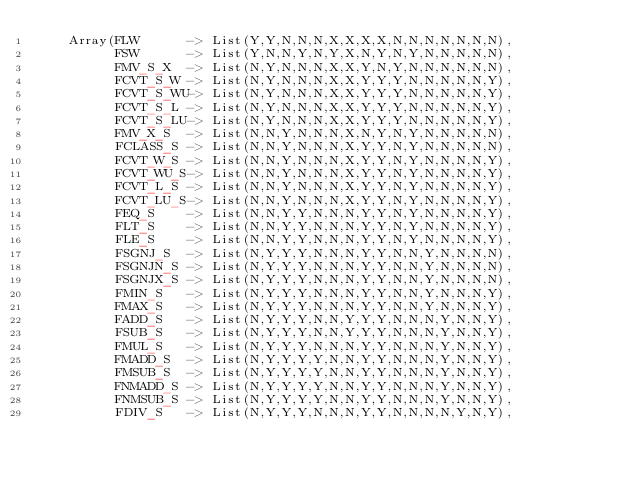Convert code to text. <code><loc_0><loc_0><loc_500><loc_500><_Scala_>    Array(FLW      -> List(Y,Y,N,N,N,X,X,X,X,N,N,N,N,N,N,N),
          FSW      -> List(Y,N,N,Y,N,Y,X,N,Y,N,Y,N,N,N,N,N),
          FMV_S_X  -> List(N,Y,N,N,N,X,X,Y,N,Y,N,N,N,N,N,N),
          FCVT_S_W -> List(N,Y,N,N,N,X,X,Y,Y,Y,N,N,N,N,N,Y),
          FCVT_S_WU-> List(N,Y,N,N,N,X,X,Y,Y,Y,N,N,N,N,N,Y),
          FCVT_S_L -> List(N,Y,N,N,N,X,X,Y,Y,Y,N,N,N,N,N,Y),
          FCVT_S_LU-> List(N,Y,N,N,N,X,X,Y,Y,Y,N,N,N,N,N,Y),
          FMV_X_S  -> List(N,N,Y,N,N,N,X,N,Y,N,Y,N,N,N,N,N),
          FCLASS_S -> List(N,N,Y,N,N,N,X,Y,Y,N,Y,N,N,N,N,N),
          FCVT_W_S -> List(N,N,Y,N,N,N,X,Y,Y,N,Y,N,N,N,N,Y),
          FCVT_WU_S-> List(N,N,Y,N,N,N,X,Y,Y,N,Y,N,N,N,N,Y),
          FCVT_L_S -> List(N,N,Y,N,N,N,X,Y,Y,N,Y,N,N,N,N,Y),
          FCVT_LU_S-> List(N,N,Y,N,N,N,X,Y,Y,N,Y,N,N,N,N,Y),
          FEQ_S    -> List(N,N,Y,Y,N,N,N,Y,Y,N,Y,N,N,N,N,Y),
          FLT_S    -> List(N,N,Y,Y,N,N,N,Y,Y,N,Y,N,N,N,N,Y),
          FLE_S    -> List(N,N,Y,Y,N,N,N,Y,Y,N,Y,N,N,N,N,Y),
          FSGNJ_S  -> List(N,Y,Y,Y,N,N,N,Y,Y,N,N,Y,N,N,N,N),
          FSGNJN_S -> List(N,Y,Y,Y,N,N,N,Y,Y,N,N,Y,N,N,N,N),
          FSGNJX_S -> List(N,Y,Y,Y,N,N,N,Y,Y,N,N,Y,N,N,N,N),
          FMIN_S   -> List(N,Y,Y,Y,N,N,N,Y,Y,N,N,Y,N,N,N,Y),
          FMAX_S   -> List(N,Y,Y,Y,N,N,N,Y,Y,N,N,Y,N,N,N,Y),
          FADD_S   -> List(N,Y,Y,Y,N,N,Y,Y,Y,N,N,N,Y,N,N,Y),
          FSUB_S   -> List(N,Y,Y,Y,N,N,Y,Y,Y,N,N,N,Y,N,N,Y),
          FMUL_S   -> List(N,Y,Y,Y,N,N,N,Y,Y,N,N,N,Y,N,N,Y),
          FMADD_S  -> List(N,Y,Y,Y,Y,N,N,Y,Y,N,N,N,Y,N,N,Y),
          FMSUB_S  -> List(N,Y,Y,Y,Y,N,N,Y,Y,N,N,N,Y,N,N,Y),
          FNMADD_S -> List(N,Y,Y,Y,Y,N,N,Y,Y,N,N,N,Y,N,N,Y),
          FNMSUB_S -> List(N,Y,Y,Y,Y,N,N,Y,Y,N,N,N,Y,N,N,Y),
          FDIV_S   -> List(N,Y,Y,Y,N,N,N,Y,Y,N,N,N,N,Y,N,Y),</code> 